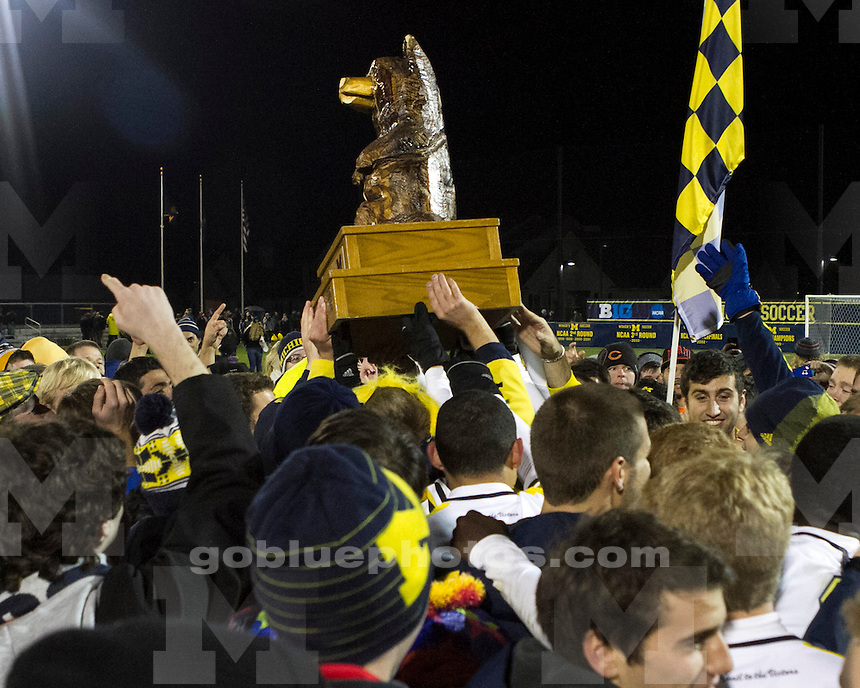What details can you see that suggest this trophy is particularly important? The trophy itself, prominently large and golden, signifies its importance, held high by several people, which underscores its value and the honor of possessing it. The fact that it's in the form of a wolverine, which might be the mascot of the group represented by the 'M' symbol, suggests it's not only a sports trophy but also an emblem of school spirit and pride. The intense focus of all present and the central placement of the trophy in the celebration are clear indicators of its significance. 